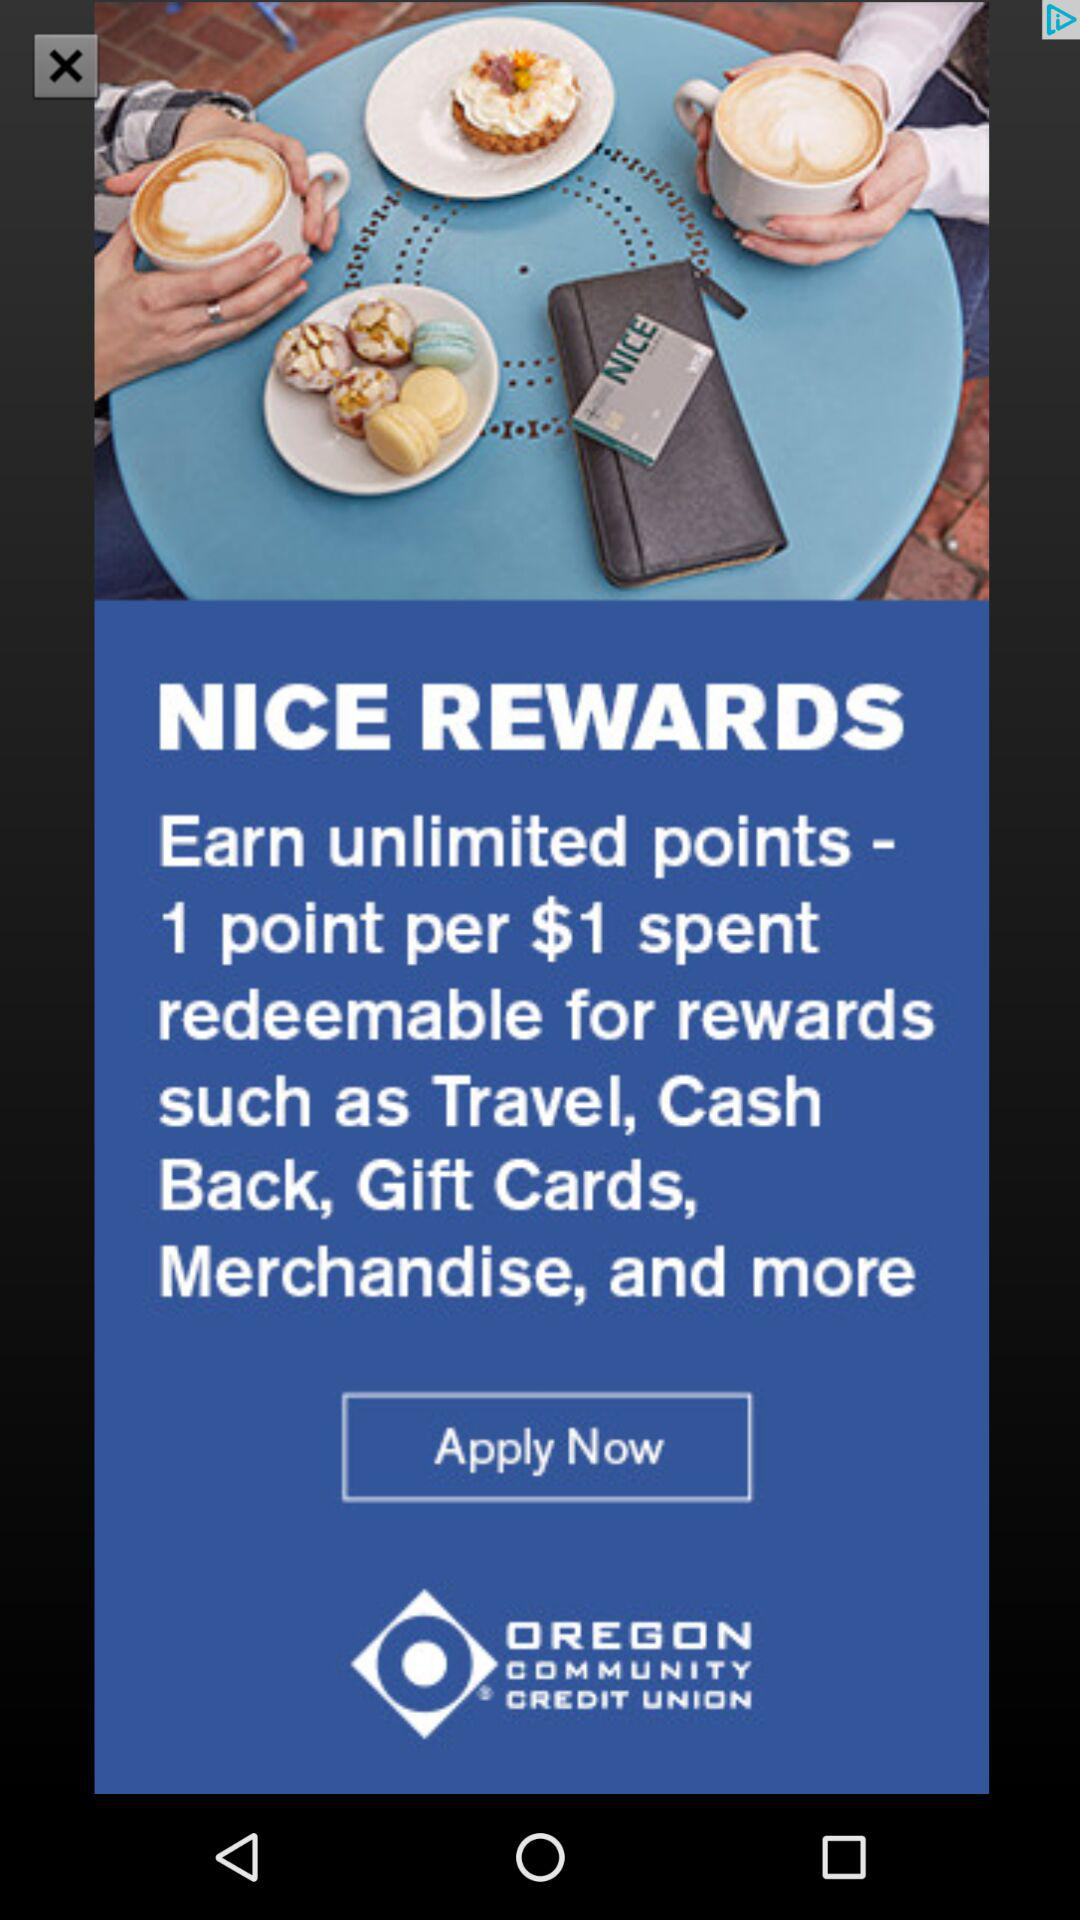What is the currency for the rewards? The currency is $. 